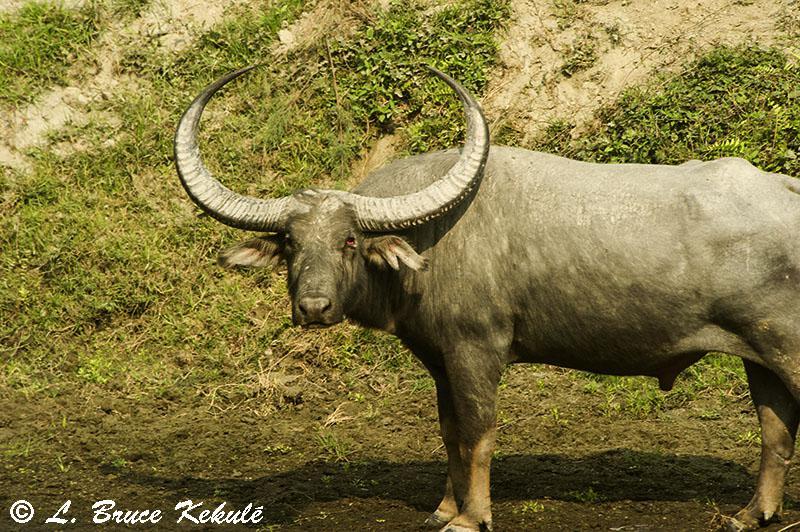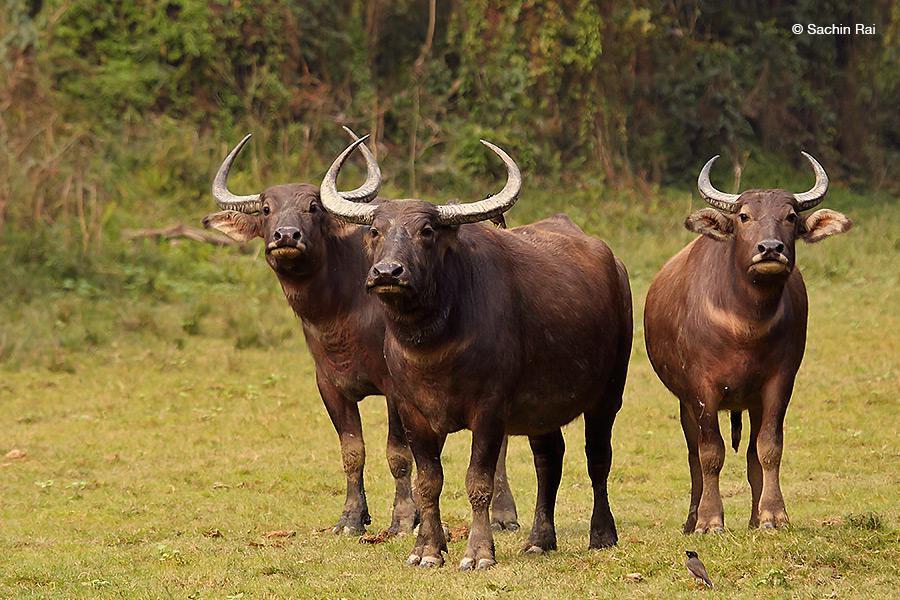The first image is the image on the left, the second image is the image on the right. Examine the images to the left and right. Is the description "Left image shows one water buffalo standing in profile, with body turned leftward." accurate? Answer yes or no. Yes. The first image is the image on the left, the second image is the image on the right. Analyze the images presented: Is the assertion "There are more animals in the image on the right than in the image on the left." valid? Answer yes or no. Yes. 